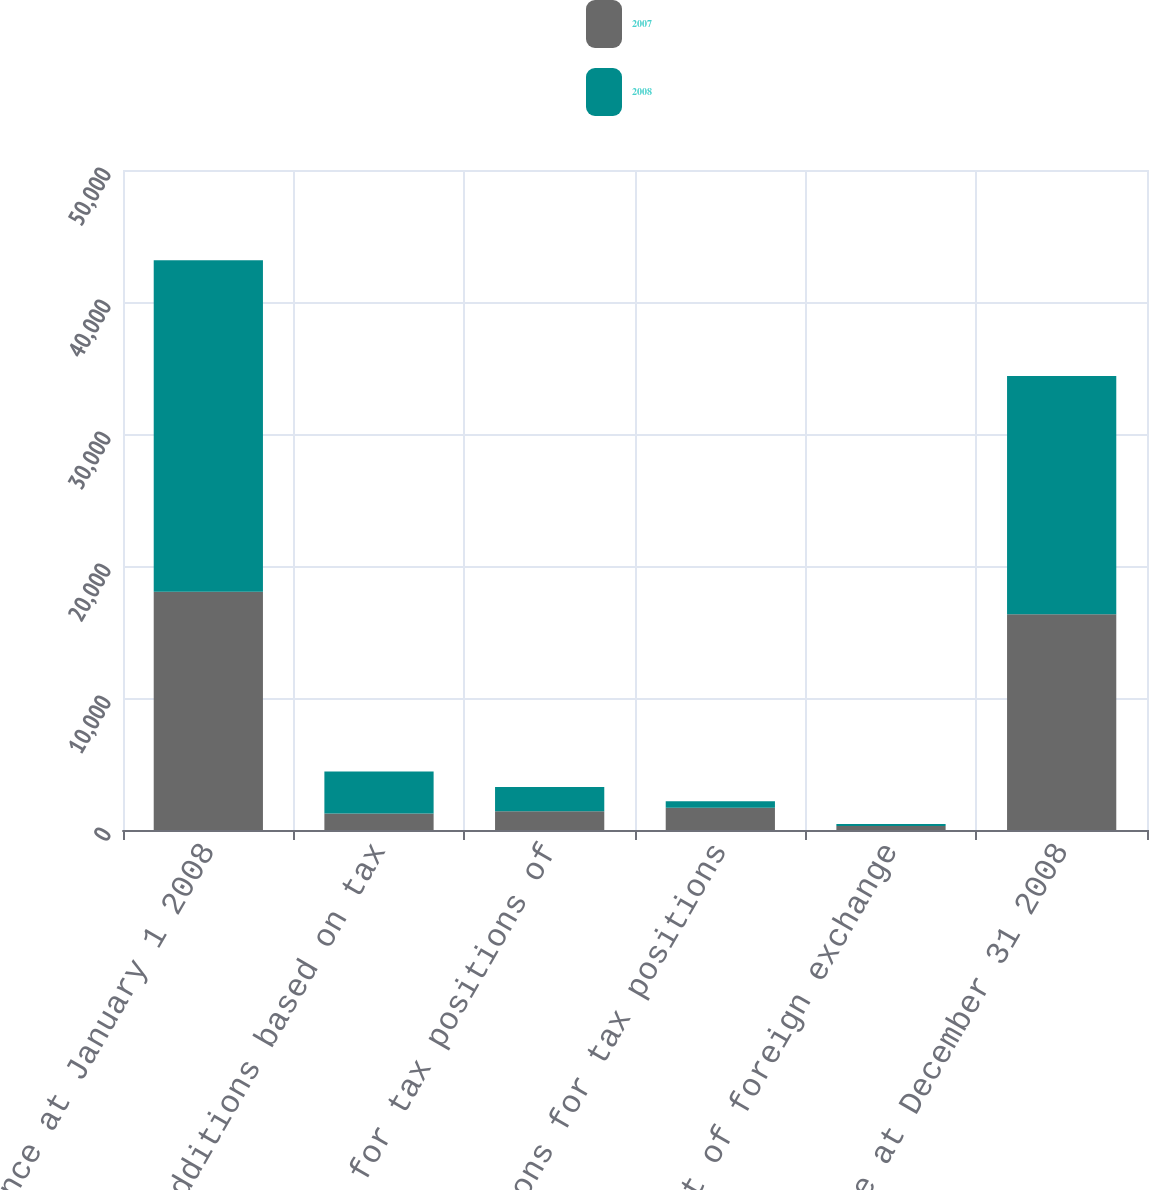Convert chart. <chart><loc_0><loc_0><loc_500><loc_500><stacked_bar_chart><ecel><fcel>Balance at January 1 2008<fcel>Additions based on tax<fcel>Additions for tax positions of<fcel>Reductions for tax positions<fcel>Impact of foreign exchange<fcel>Balance at December 31 2008<nl><fcel>2007<fcel>18051<fcel>1253<fcel>1424<fcel>1692<fcel>297<fcel>16347<nl><fcel>2008<fcel>25105<fcel>3174<fcel>1831<fcel>488<fcel>163<fcel>18051<nl></chart> 